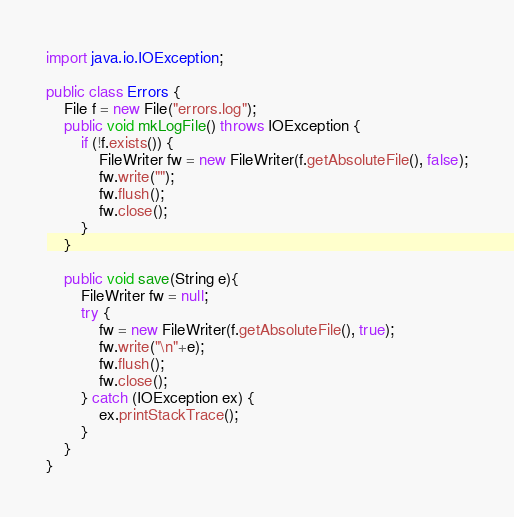Convert code to text. <code><loc_0><loc_0><loc_500><loc_500><_Java_>import java.io.IOException;

public class Errors {
    File f = new File("errors.log");
    public void mkLogFile() throws IOException {
        if (!f.exists()) {
            FileWriter fw = new FileWriter(f.getAbsoluteFile(), false);
            fw.write("");
            fw.flush();
            fw.close();
        }
    }

    public void save(String e){
        FileWriter fw = null;
        try {
            fw = new FileWriter(f.getAbsoluteFile(), true);
            fw.write("\n"+e);
            fw.flush();
            fw.close();
        } catch (IOException ex) {
            ex.printStackTrace();
        }
    }
}
</code> 